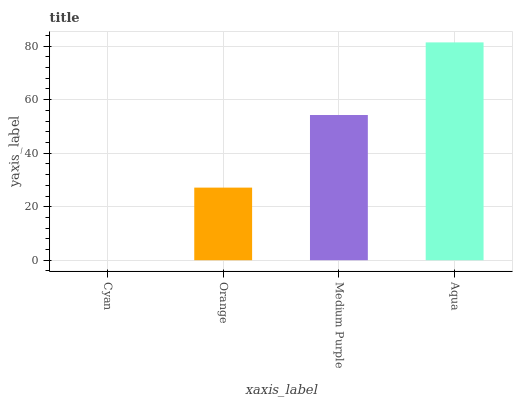Is Cyan the minimum?
Answer yes or no. Yes. Is Aqua the maximum?
Answer yes or no. Yes. Is Orange the minimum?
Answer yes or no. No. Is Orange the maximum?
Answer yes or no. No. Is Orange greater than Cyan?
Answer yes or no. Yes. Is Cyan less than Orange?
Answer yes or no. Yes. Is Cyan greater than Orange?
Answer yes or no. No. Is Orange less than Cyan?
Answer yes or no. No. Is Medium Purple the high median?
Answer yes or no. Yes. Is Orange the low median?
Answer yes or no. Yes. Is Orange the high median?
Answer yes or no. No. Is Cyan the low median?
Answer yes or no. No. 